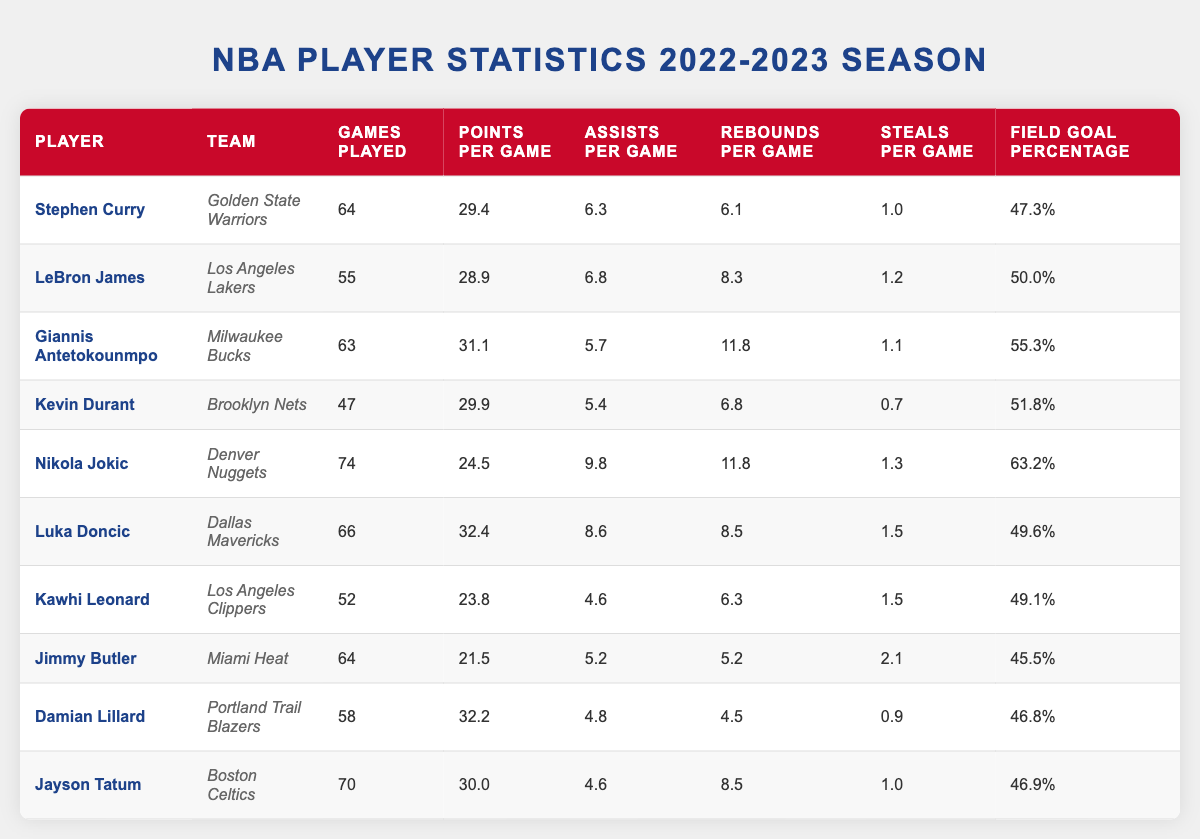What player had the highest points per game? Looking at the "Points Per Game" column, Luka Doncic scored 32.4 points per game, which is higher than the other players listed.
Answer: Luka Doncic Which team did Kevin Durant play for? The "Team" column indicates that Kevin Durant played for the Brooklyn Nets.
Answer: Brooklyn Nets What is the average number of games played by the players listed? To calculate the average, sum the "Games Played": (64 + 55 + 63 + 47 + 74 + 66 + 52 + 64 + 58 + 70) =  646, and divide by the number of players (10): 646/10 = 64.6.
Answer: 64.6 Did Stephen Curry have more assists per game than Damian Lillard? Stephen Curry's assists per game are 6.3, while Damian Lillard's are 4.8, which confirms that Curry had more assists.
Answer: Yes What is the total number of rebounds per game for all players combined? To find the total rebounds per game, sum the "Rebounds Per Game": (6.1 + 8.3 + 11.8 + 6.8 + 11.8 + 8.5 + 6.3 + 5.2 + 4.5 + 8.5) = 69.4.
Answer: 69.4 Who had the lowest field goal percentage among the players? Compare the "Field Goal Percentage" values, and Jimmy Butler had the lowest at 45.5%.
Answer: Jimmy Butler What is the difference in points per game between Luka Doncic and Giannis Antetokounmpo? Luka Doncic scored 32.4 points per game, and Giannis Antetokounmpo scored 31.1. The difference is 32.4 - 31.1 = 1.3.
Answer: 1.3 Which player had the highest field goal percentage? The "Field Goal Percentage" column shows that Nikola Jokic had the highest percentage at 63.2%.
Answer: Nikola Jokic What percentage of games did LeBron James play compared to the average games played? LeBron James played 55 games. The average games played is 64.6. Calculate the percentage: (55 / 64.6) * 100 ≈ 85.2%.
Answer: 85.2% Which player had the most steals per game? Looking at the "Steals Per Game" column, Jimmy Butler had the highest with 2.1 steals per game.
Answer: Jimmy Butler 